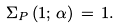Convert formula to latex. <formula><loc_0><loc_0><loc_500><loc_500>\Sigma _ { P } \left ( 1 ; \, \alpha \right ) \, = \, 1 .</formula> 